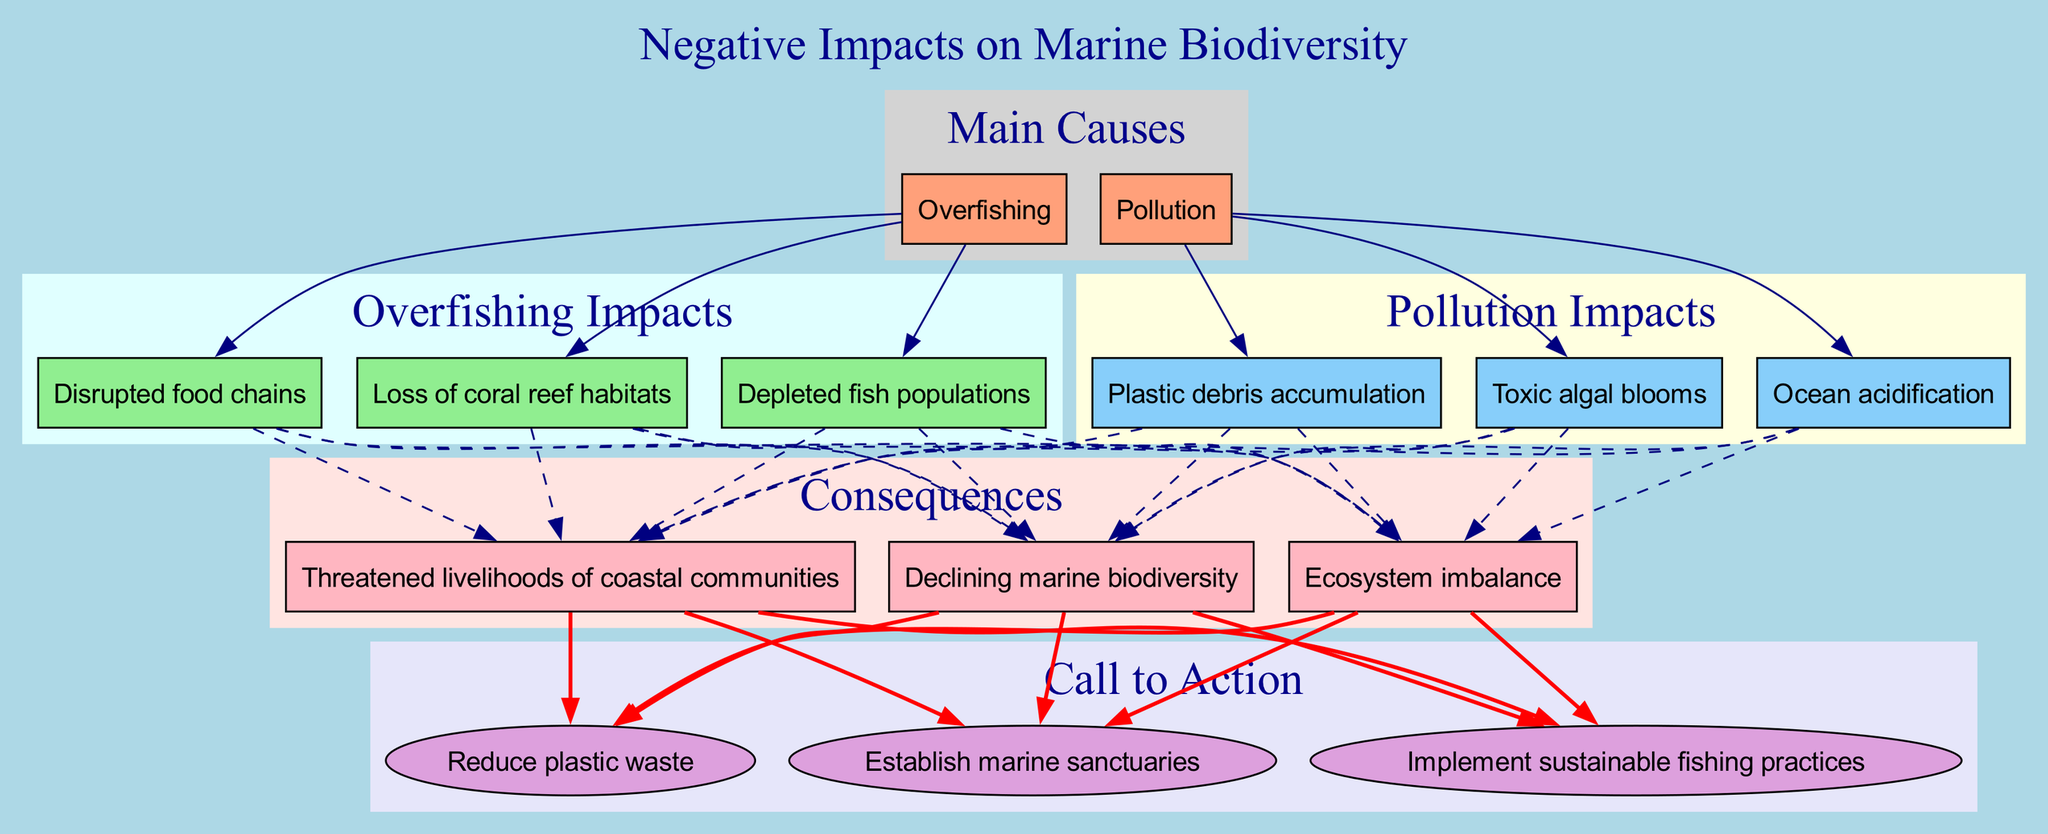What are the main causes illustrated in the diagram? The diagram explicitly lists "Overfishing" and "Pollution" as the main causes at the top. These two nodes are distinctly shown in the main node area of the diagram.
Answer: Overfishing, Pollution How many impacts are listed under overfishing? Upon inspecting the section dedicated to "Overfishing Impacts", there are three impacts: "Depleted fish populations", "Disrupted food chains", and "Loss of coral reef habitats". Counting these, we conclude that there are three impacts.
Answer: 3 Which impact is linked to ocean acidification? The diagram shows "Ocean acidification" as an impact of "Pollution". By following the edge from "Pollution," we can identify that "Ocean acidification" is directly connected to it.
Answer: Ocean acidification What is the relationship between plastic debris accumulation and marine biodiversity? "Plastic debris accumulation" is listed as an impact of "Pollution", which has a dashed edge connecting to "Declining marine biodiversity", indicating that it negatively influences biodiversity. Thus, the relationship is that plastic debris accumulation leads to declining marine biodiversity.
Answer: Declining marine biodiversity How does overfishing disrupt the food chain? "Disrupted food chains" is shown as one of the three impacts resulting from "Overfishing". The connection implies that through overfishing, key species may be removed, leading to a cascade of disruptions in the food chain, hence negatively affecting marine ecosystems.
Answer: Disrupted food chains What are the three consequences of the impacts listed in the diagram? The diagram outlines three specific consequences following the effects of overfishing and pollution: "Declining marine biodiversity", "Ecosystem imbalance", and "Threatened livelihoods of coastal communities". Thus, these three consequences summarize the broader implications of the impacts.
Answer: Declining marine biodiversity, Ecosystem imbalance, Threatened livelihoods of coastal communities What is the recommended action to address pollution mentioned in the diagram? The diagram lists "Reduce plastic waste" as one of the calls to action, signifying that it is a direct recommendation to mitigate pollution and its harmful impacts on marine biodiversity.
Answer: Reduce plastic waste What color is used for the main cause "Pollution"? In the diagram, "Pollution" appears in a light grey section along with its associated impacts. The node for "Pollution" specifically is shown in a light salmon color for clear differentiation, and then the impacts are rendered in light yellow.
Answer: light salmon Which call to action is connected to ecosystem imbalance? The diagram shows "Ecosystem imbalance" connects to "Establish marine sanctuaries", indicating that it is suggested as a measure to help counter this specific consequence. Following the dashed edge from "Ecosystem imbalance" clearly identifies this action.
Answer: Establish marine sanctuaries 